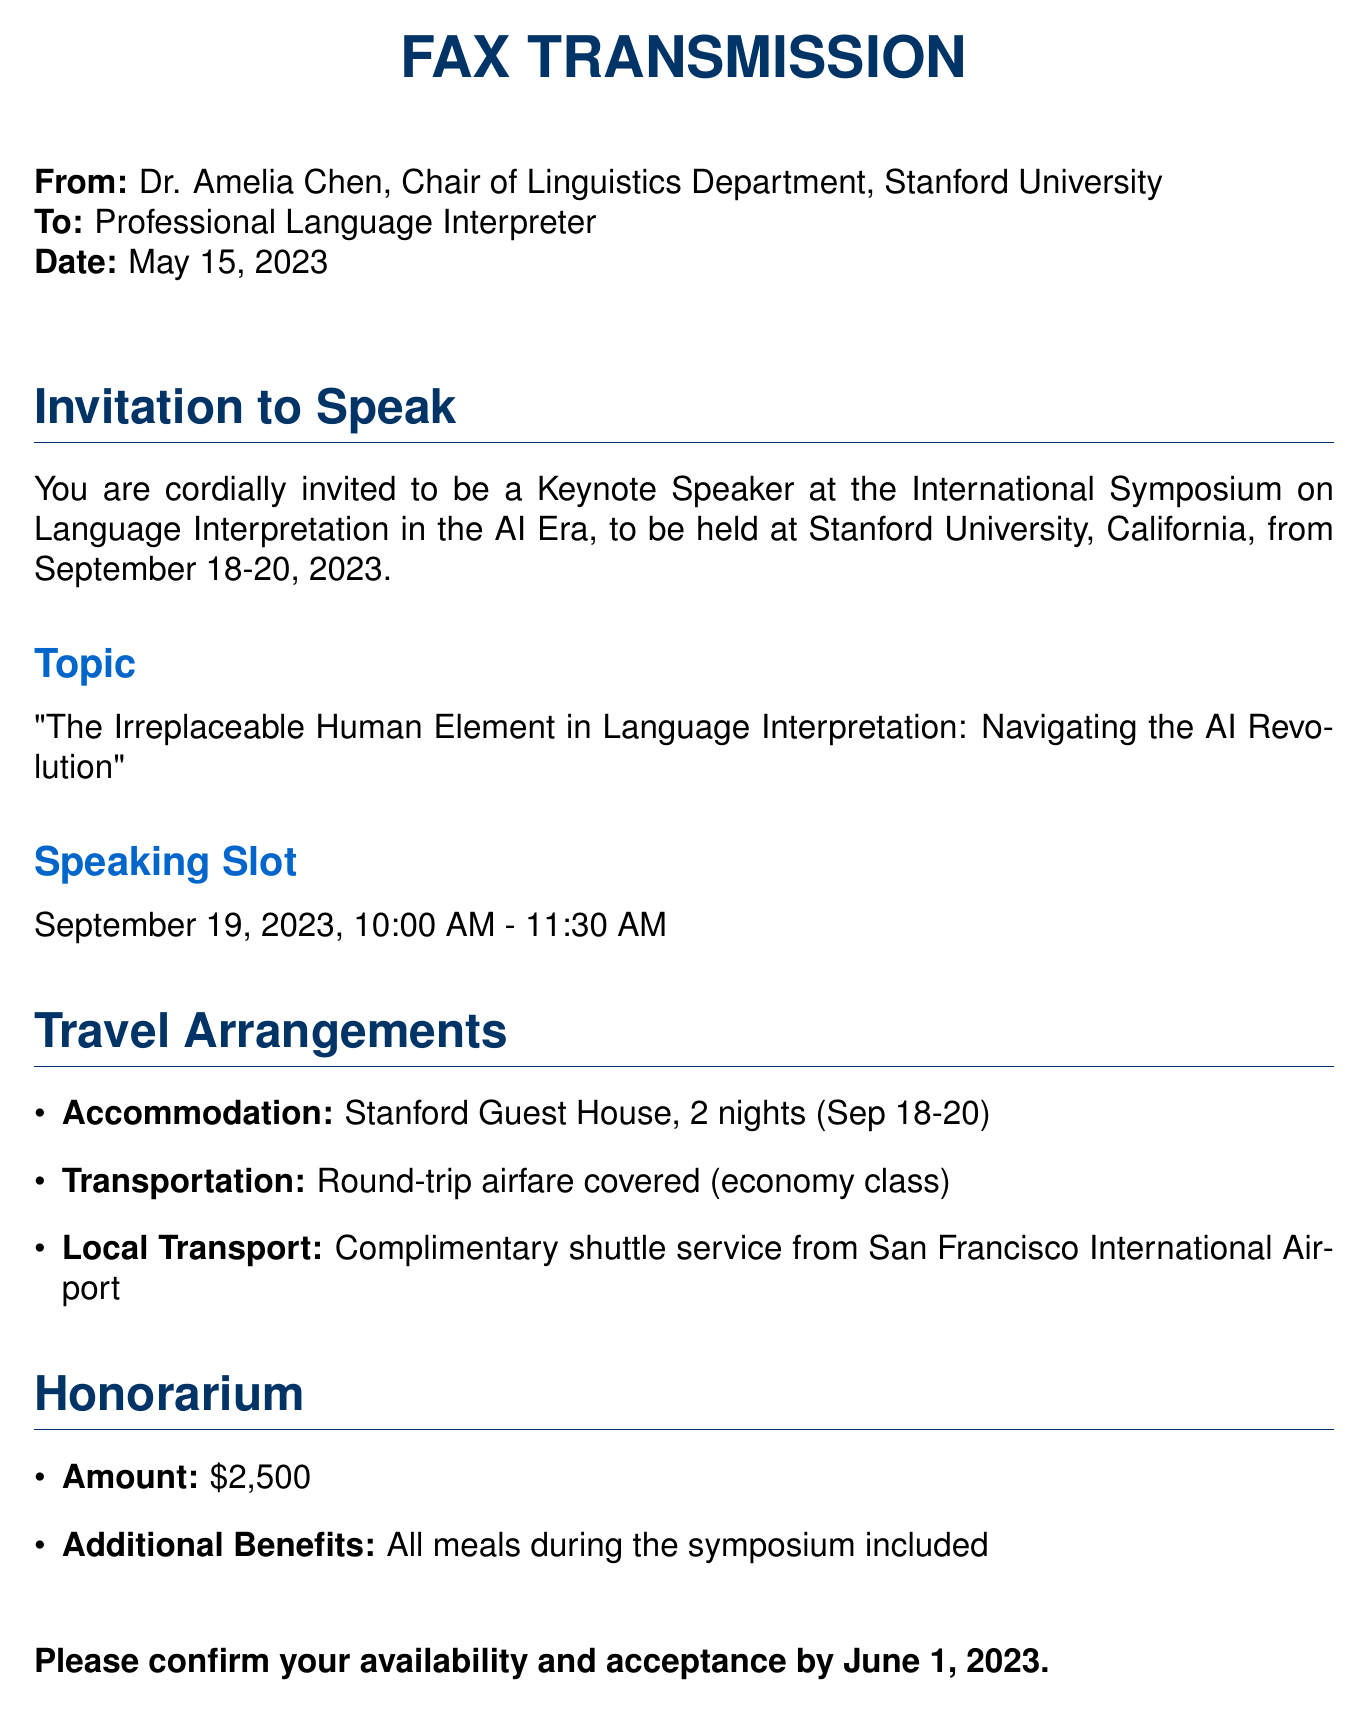What is the date of the symposium? The symposium will be held from September 18 to September 20, 2023.
Answer: September 18-20, 2023 What is the title of the keynote speech? The title of the keynote speech is "The Irreplaceable Human Element in Language Interpretation: Navigating the AI Revolution."
Answer: The Irreplaceable Human Element in Language Interpretation: Navigating the AI Revolution Who should be contacted for more information? The event coordinator listed for contact is Sarah Johnson.
Answer: Sarah Johnson What is the honorarium amount? The honorarium amount stated in the document is $2,500.
Answer: $2,500 Is accommodation provided? The document confirms that accommodation is provided at Stanford Guest House for two nights.
Answer: Yes What time is the speaking slot? The scheduled time for the speaking slot is from 10:00 AM to 11:30 AM.
Answer: 10:00 AM - 11:30 AM What is included with the honorarium? Meals during the symposium are included with the honorarium.
Answer: All meals during the symposium By what date should availability be confirmed? The document specifies that availability should be confirmed by June 1, 2023.
Answer: June 1, 2023 